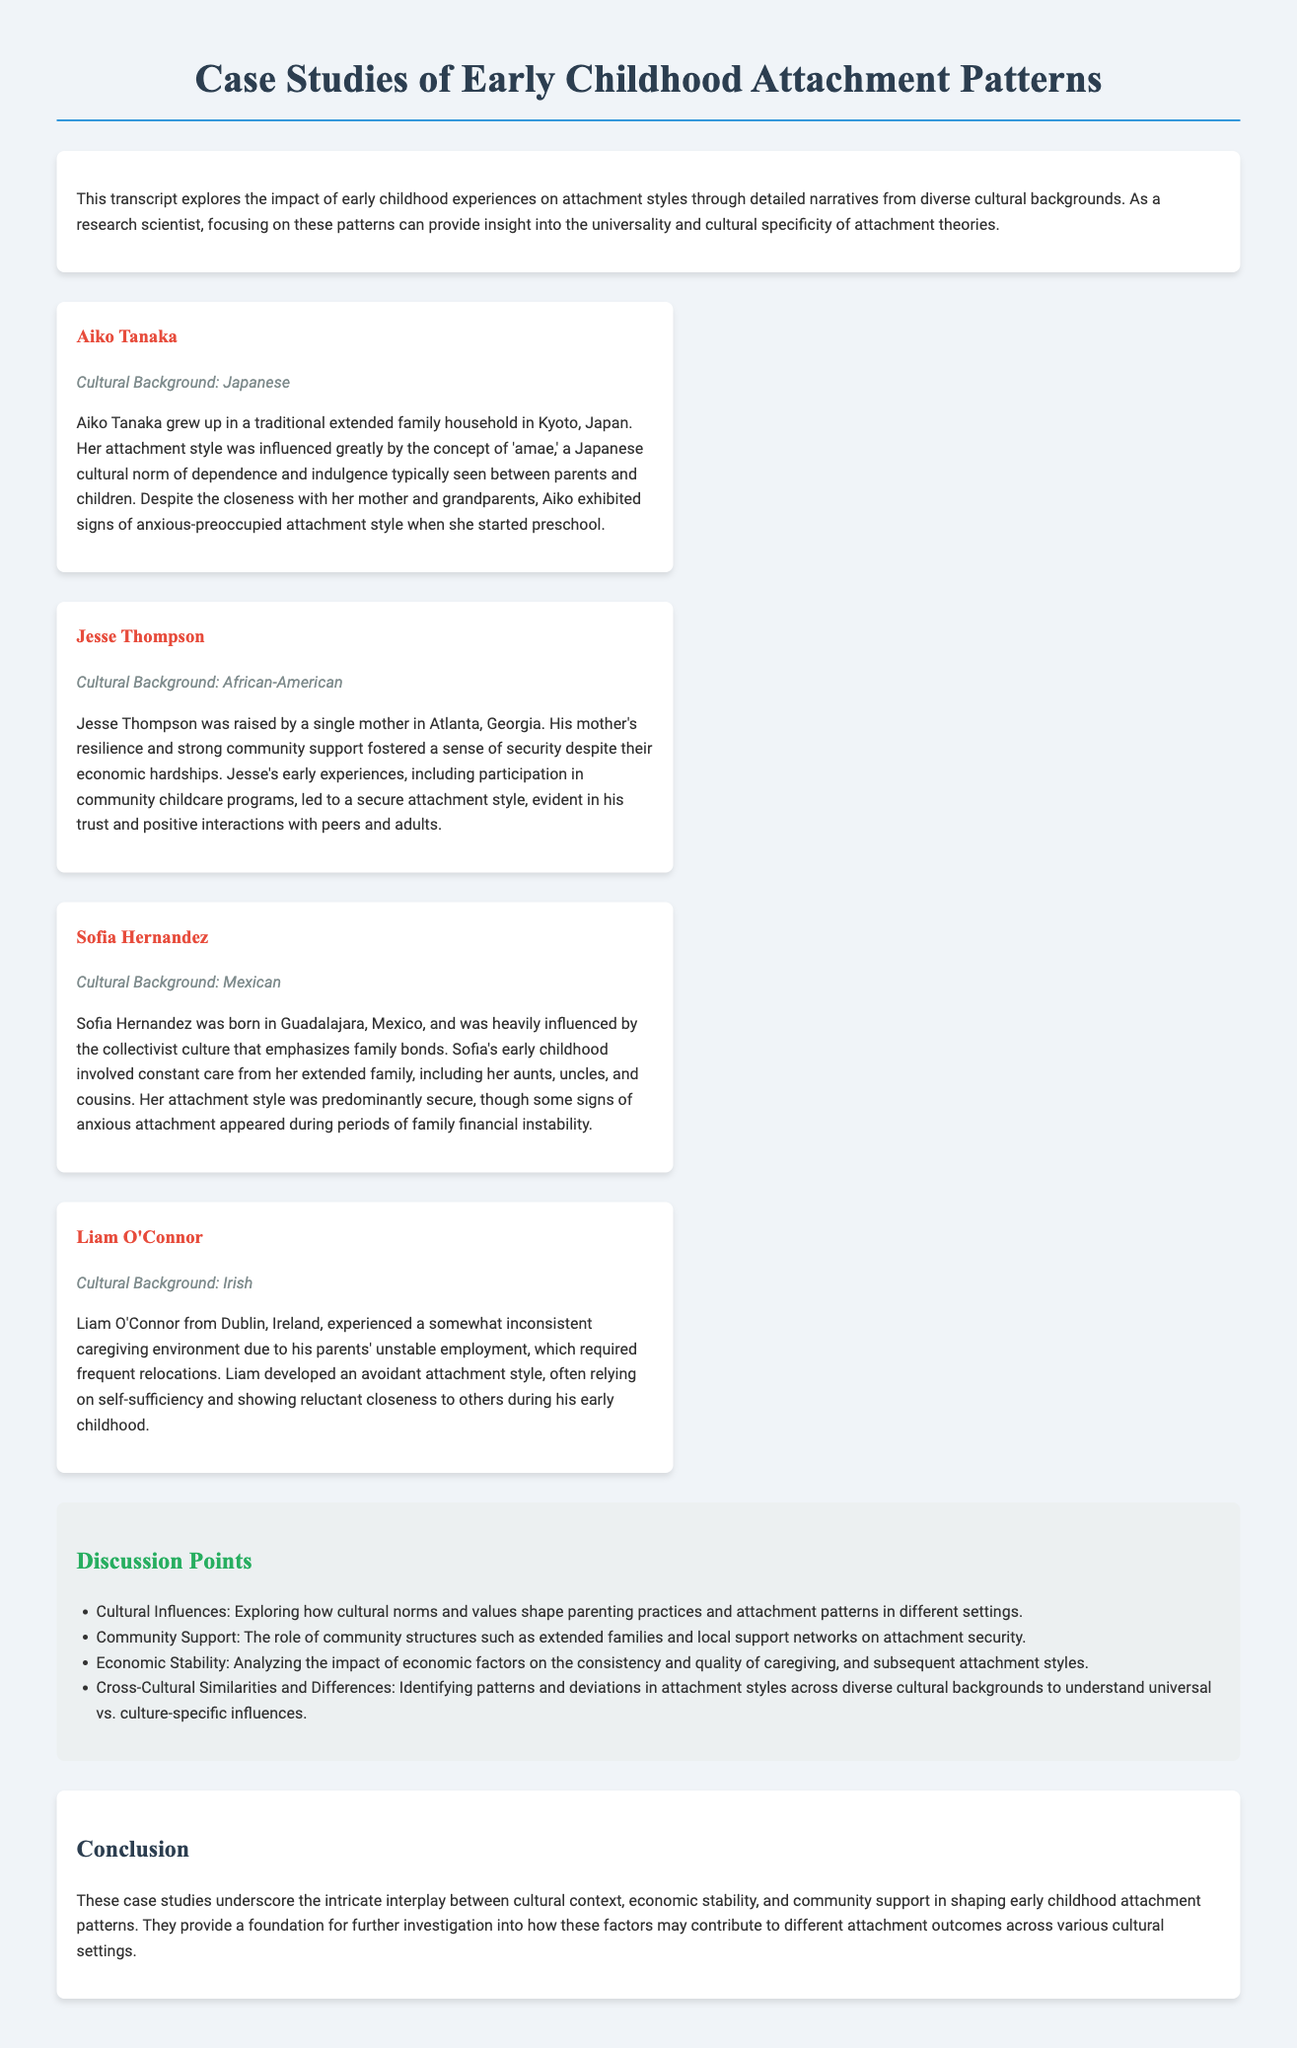What is the cultural background of Aiko Tanaka? Aiko Tanaka's cultural background is mentioned in the case study, which indicates she is Japanese.
Answer: Japanese What attachment style did Jesse Thompson develop? The document states that Jesse Thompson developed a secure attachment style due to his early experiences and community support.
Answer: Secure How many case studies are presented in the document? The document lists four individuals, indicating that there are four case studies discussed.
Answer: Four What cultural influence is associated with Sofia Hernandez's upbringing? The document mentions that Sofia Hernandez was influenced by a collectivist culture that emphasizes family bonds.
Answer: Collectivist culture What was Liam O'Connor's attachment style primarily characterized as? The document describes Liam O'Connor's attachment style as avoidant due to his inconsistent caregiving environment.
Answer: Avoidant What role does community support play in attachment styles according to the discussion points? According to the discussion points, the role of community structures such as extended families is crucial in affecting attachment security.
Answer: Attachment security Which region is Jesse Thompson associated with? Jesse Thompson is raised in Atlanta, Georgia, as specified in the case study.
Answer: Atlanta, Georgia How does economic stability impact attachment styles based on the document? The document discusses that economic factors influence the consistency and quality of caregiving and subsequent attachment styles.
Answer: Consistency and quality of caregiving 